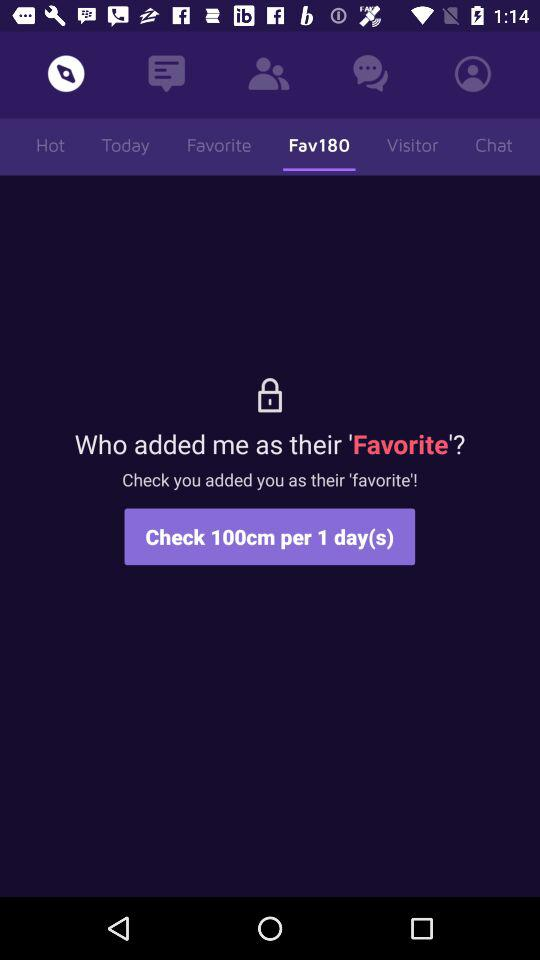How many days do I have left to check if I was added as a favorite?
Answer the question using a single word or phrase. 1 day(s) 